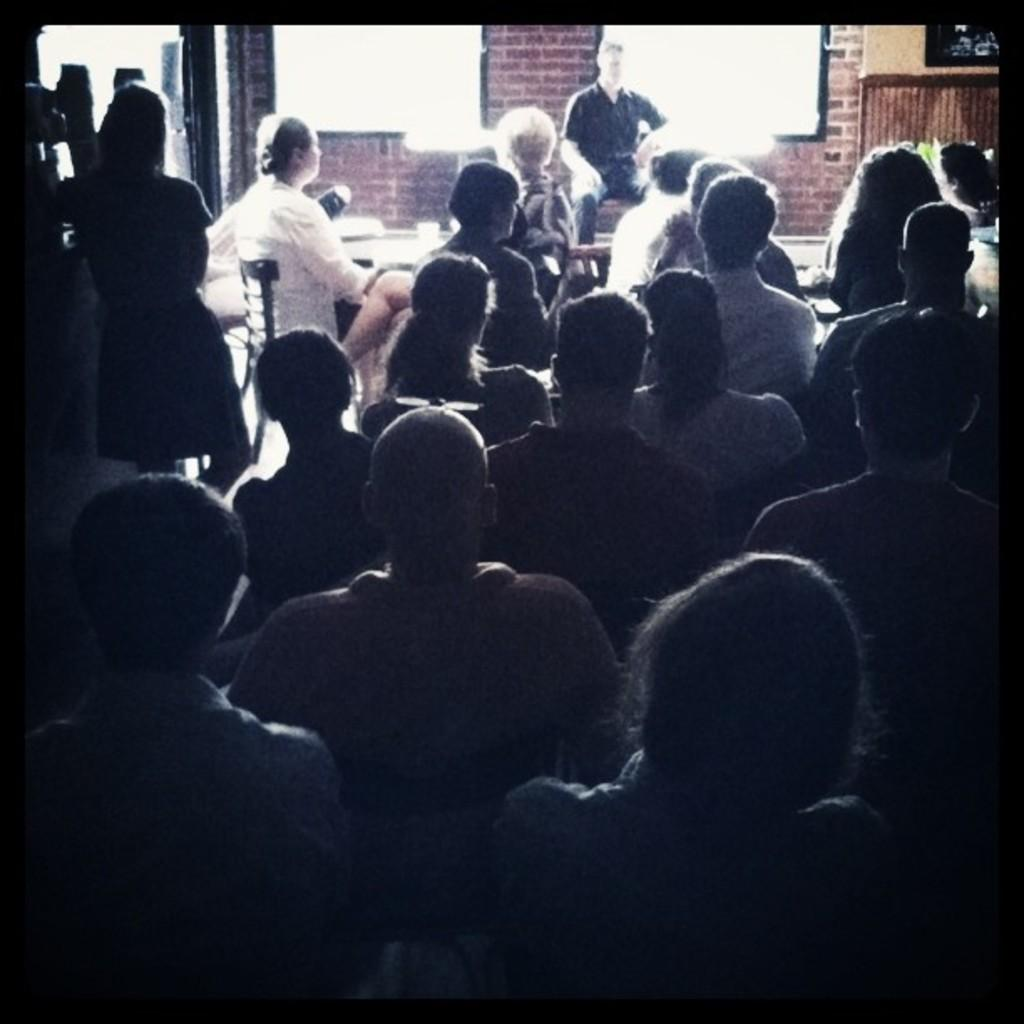How many people are in the image? There is a group of persons in the image. What are some of the people in the image doing? Some persons are standing, and some are sitting in chairs. What can be seen on the wall in the image? There are screens attached to the wall. Can you describe the wall in the image? The wall is visible at the top of the image. What type of substance is being taught in the class depicted in the image? There is no class present in the image, so it is not possible to determine what, if any, substance is being taught. 